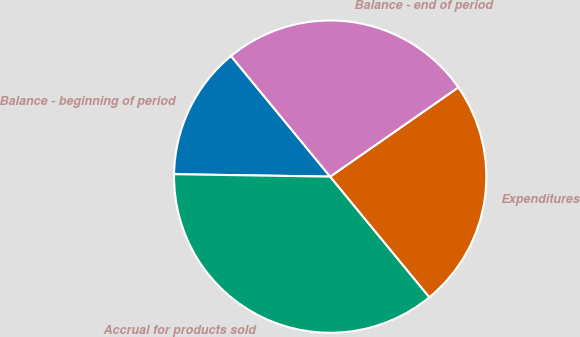Convert chart to OTSL. <chart><loc_0><loc_0><loc_500><loc_500><pie_chart><fcel>Balance - beginning of period<fcel>Accrual for products sold<fcel>Expenditures<fcel>Balance - end of period<nl><fcel>13.8%<fcel>36.2%<fcel>23.73%<fcel>26.27%<nl></chart> 